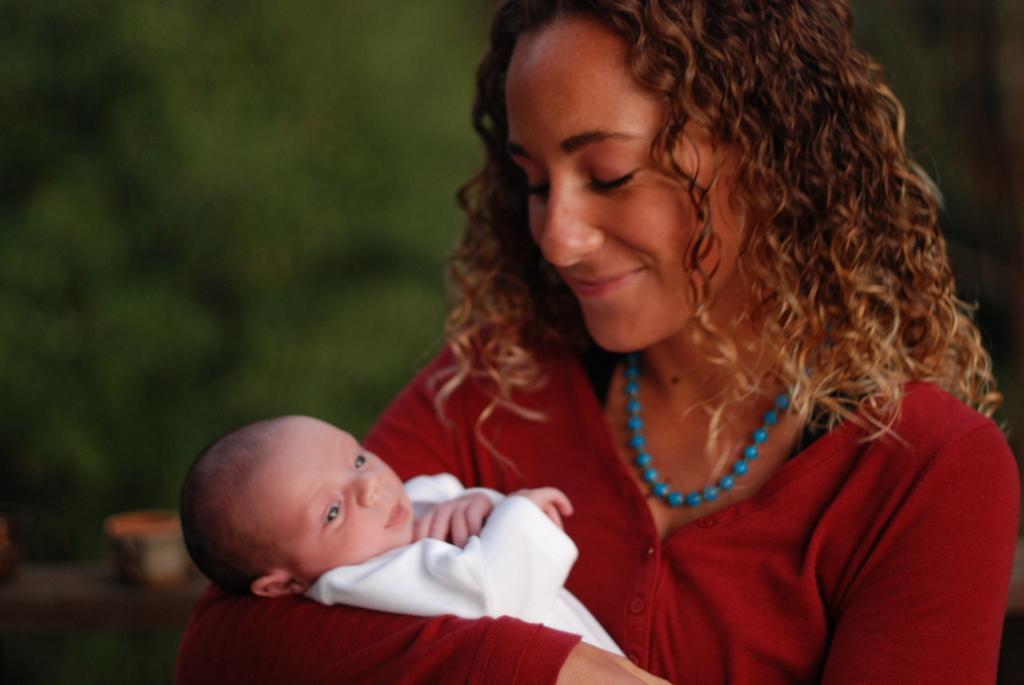How would you summarize this image in a sentence or two? In the picture we can see a woman holding a baby and the woman is wearing a red color dress and with a blue color necklace and with a brown curly hair and to the baby we can see white dress. 